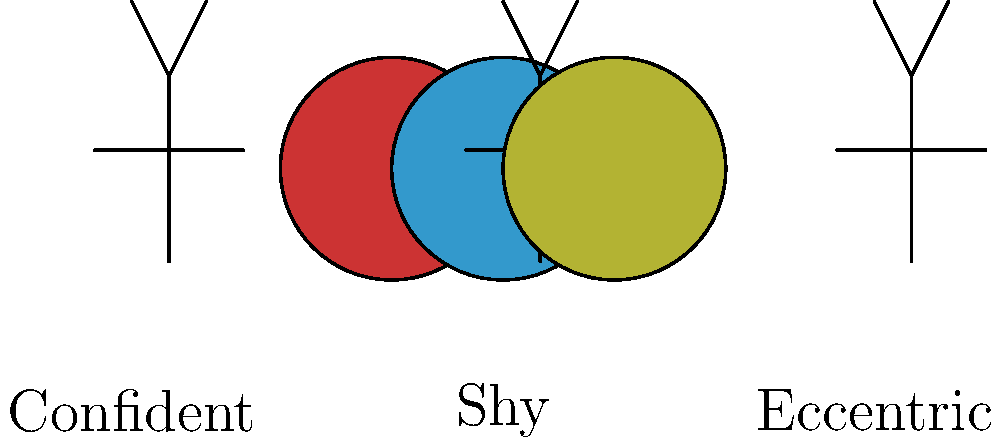As a writer bringing character concepts to life, how might the color choices in these costume design sketches influence the personality traits of the characters they represent? To answer this question, let's analyze the color choices in the costume design sketches and their potential influence on character personality:

1. Red sketch (left):
   - Red is often associated with confidence, passion, and energy.
   - This could suggest a bold, outgoing character who is not afraid to stand out.

2. Blue sketch (center):
   - Blue typically represents calmness, introspection, and reliability.
   - This might indicate a more reserved or thoughtful character, possibly shy or introverted.

3. Yellow sketch (right):
   - Yellow is often linked to creativity, optimism, and uniqueness.
   - This could imply an eccentric or unconventional character with a vibrant personality.

As a writer, you would use these visual cues to inform and enhance your character development:

1. The confident character (red) might have dialogue and actions that reflect their bold nature.
2. The shy character (blue) could have more internal monologue or hesitant speech patterns.
3. The eccentric character (yellow) might have unusual hobbies or quirky mannerisms in your story.

By aligning the characters' personalities with their costume colors, you create a cohesive and visually reinforced character concept that readers can easily grasp and remember.
Answer: Color choices in costume sketches can suggest personality traits: red for confidence, blue for shyness, and yellow for eccentricity, guiding character development in writing. 